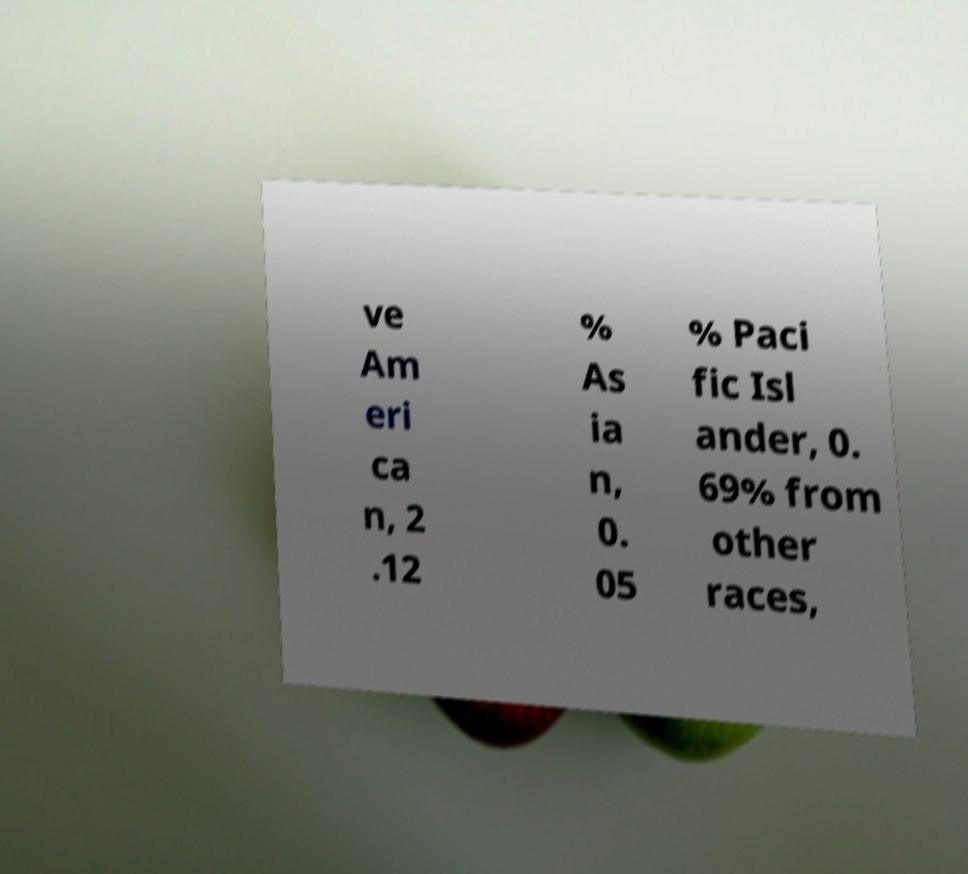Can you accurately transcribe the text from the provided image for me? ve Am eri ca n, 2 .12 % As ia n, 0. 05 % Paci fic Isl ander, 0. 69% from other races, 